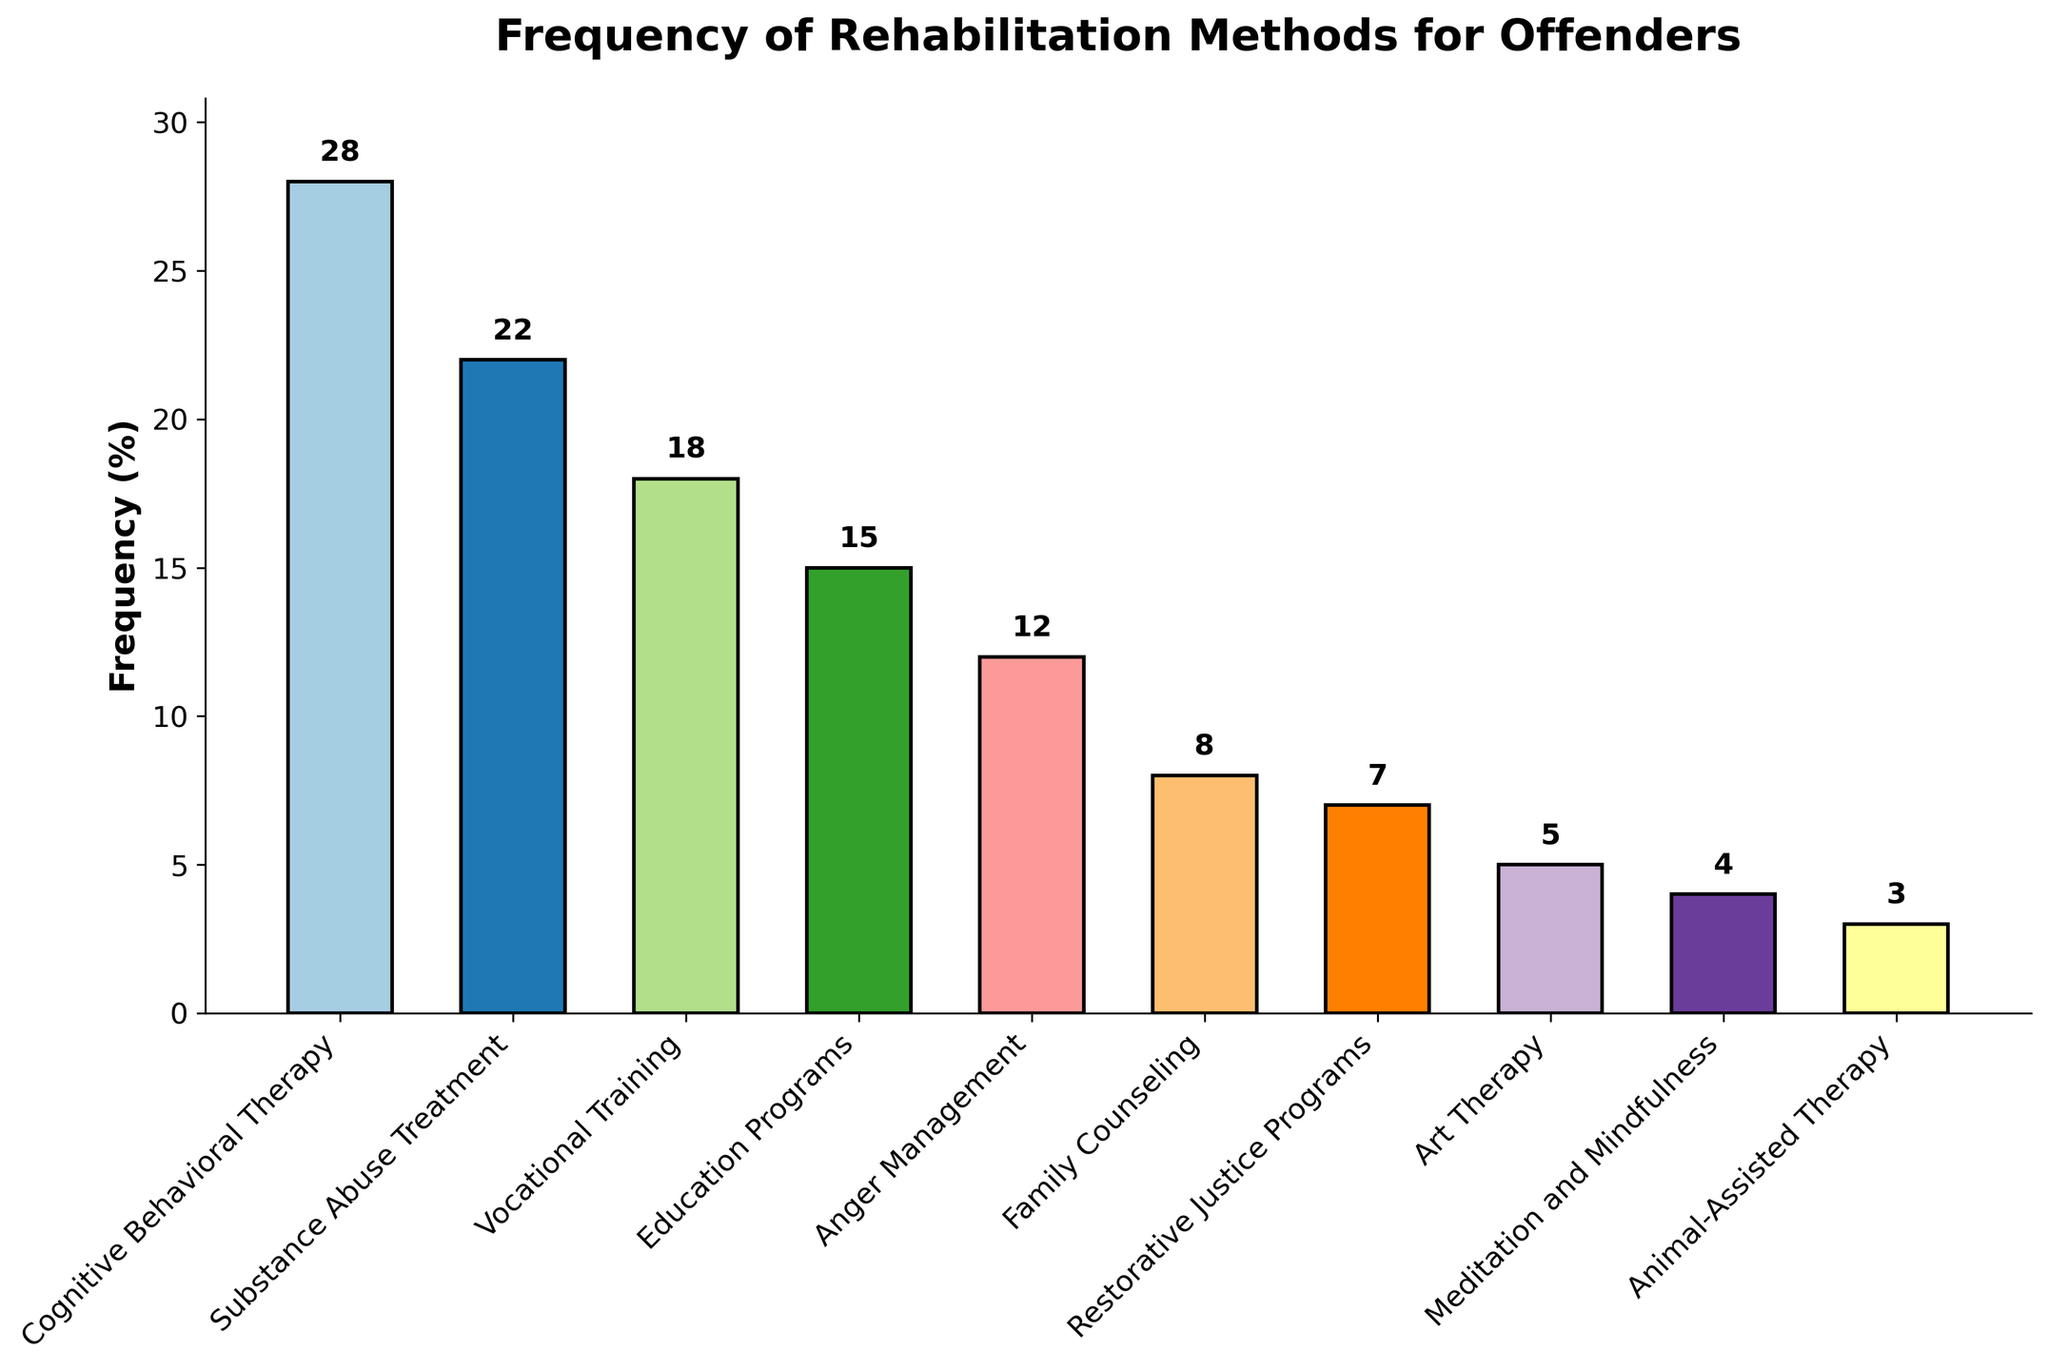Which rehabilitation method is used most frequently? To determine which rehabilitation method is used most frequently, identify the bar with the greatest height. The height represents the frequency (28%) of Cognitive Behavioral Therapy, making it the most frequent method.
Answer: Cognitive Behavioral Therapy How much more frequently is Substance Abuse Treatment used compared to Art Therapy? To calculate how much more frequently Substance Abuse Treatment (22%) is used compared to Art Therapy (5%), subtract 5 from 22: 22 - 5 = 17.
Answer: 17% What is the combined frequency of Vocational Training, Education Programs, and Anger Management? To find the combined frequency of Vocational Training (18%), Education Programs (15%), and Anger Management (12%), add the three values: 18 + 15 + 12 = 45.
Answer: 45% Which rehabilitation methods have a lower frequency than Family Counseling? Family Counseling has a frequency of 8%. The methods with lower frequencies are Restorative Justice Programs (7%), Art Therapy (5%), Meditation and Mindfulness (4%), and Animal-Assisted Therapy (3%).
Answer: Restorative Justice Programs, Art Therapy, Meditation and Mindfulness, Animal-Assisted Therapy What is the difference in frequency between the least used method and the most used method? The least used method is Animal-Assisted Therapy (3%), and the most used method is Cognitive Behavioral Therapy (28%). The difference in frequency is calculated by subtracting 3 from 28: 28 - 3 = 25.
Answer: 25% How does the frequency of Education Programs compare to that of Cognitive Behavioral Therapy? Education Programs have a frequency of 15%, while Cognitive Behavioral Therapy has a frequency of 28%. Cognitive Behavioral Therapy is used more frequently, and the difference is: 28 - 15 = 13.
Answer: Cognitive Behavioral Therapy is used 13% more What is the average frequency of the top four rehabilitation methods used? The top four rehabilitation methods are Cognitive Behavioral Therapy (28%), Substance Abuse Treatment (22%), Vocational Training (18%), and Education Programs (15%). Calculate the average by summing these values (28 + 22 + 18 + 15 = 83) and dividing by 4: 83 / 4 = 20.75.
Answer: 20.75% Which method is exactly in the middle of the frequency range when listed in descending order? Arranging the methods from highest to lowest frequency: Cognitive Behavioral Therapy (28%), Substance Abuse Treatment (22%), Vocational Training (18%), Education Programs (15%), Anger Management (12%), Family Counseling (8%), Restorative Justice Programs (7%), Art Therapy (5%), Meditation and Mindfulness (4%), Animal-Assisted Therapy (3%). The middle method (5th in the list) is Anger Management.
Answer: Anger Management How many methods have a frequency of 10% or more? To determine this, count the methods with a frequency of at least 10%. The methods are Cognitive Behavioral Therapy (28%), Substance Abuse Treatment (22%), Vocational Training (18%), Education Programs (15%), and Anger Management (12%).
Answer: 5 methods 